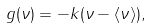<formula> <loc_0><loc_0><loc_500><loc_500>g ( \nu ) = - k ( \nu - \langle \nu \rangle ) ,</formula> 